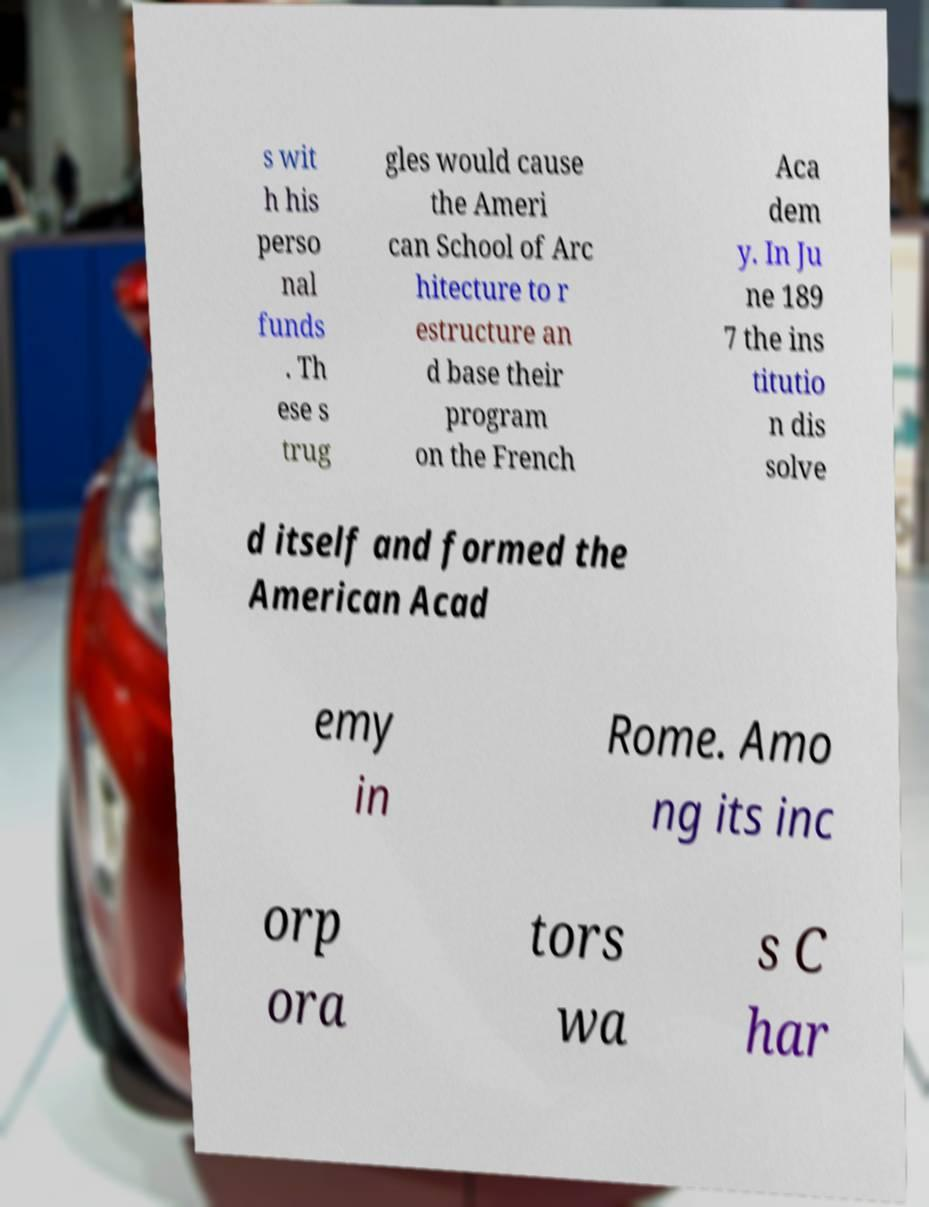For documentation purposes, I need the text within this image transcribed. Could you provide that? s wit h his perso nal funds . Th ese s trug gles would cause the Ameri can School of Arc hitecture to r estructure an d base their program on the French Aca dem y. In Ju ne 189 7 the ins titutio n dis solve d itself and formed the American Acad emy in Rome. Amo ng its inc orp ora tors wa s C har 